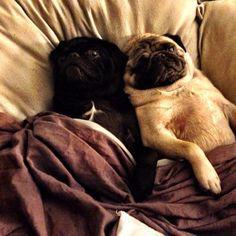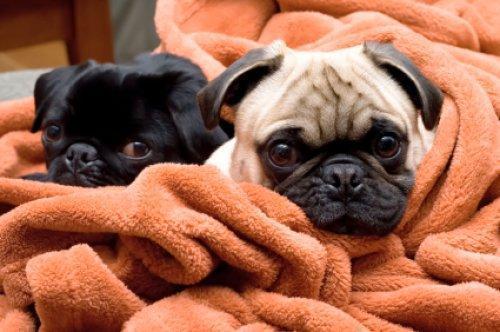The first image is the image on the left, the second image is the image on the right. For the images shown, is this caption "Two camel-colored pugs relax together on a soft surface, with one posed above the other one." true? Answer yes or no. No. The first image is the image on the left, the second image is the image on the right. Assess this claim about the two images: "The left image contains one black dog laying next to one tan dog.". Correct or not? Answer yes or no. Yes. 